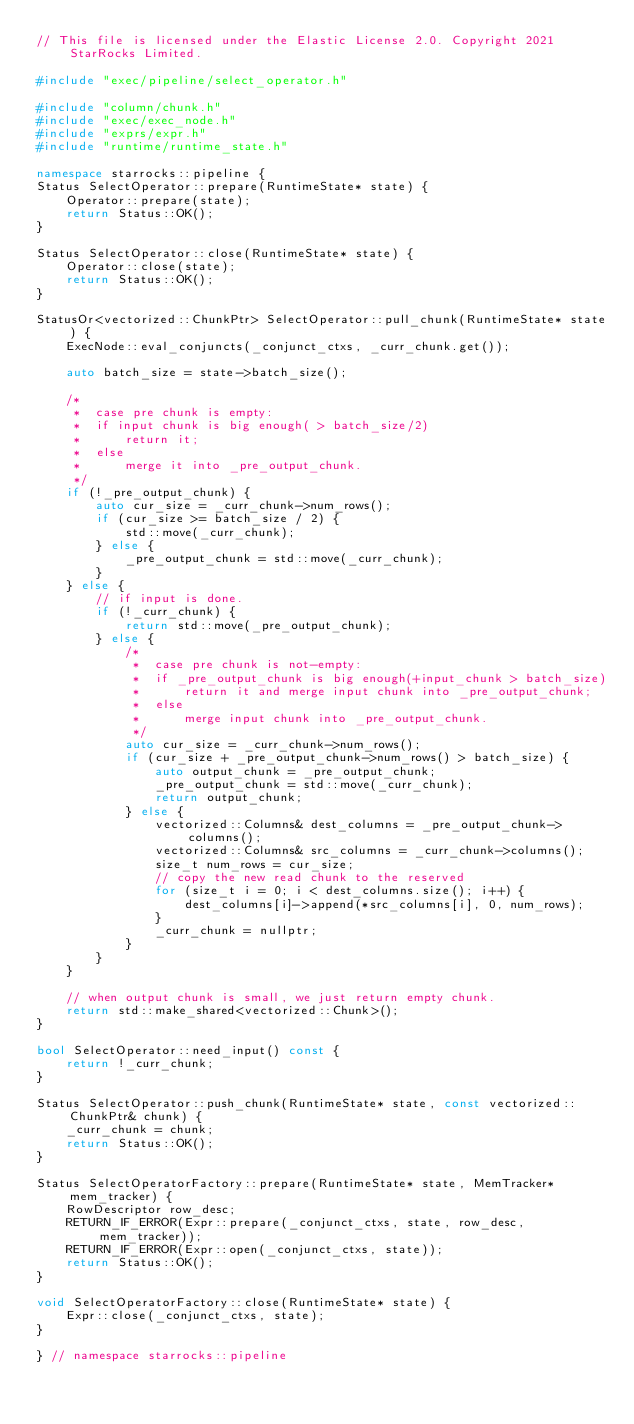<code> <loc_0><loc_0><loc_500><loc_500><_C++_>// This file is licensed under the Elastic License 2.0. Copyright 2021 StarRocks Limited.

#include "exec/pipeline/select_operator.h"

#include "column/chunk.h"
#include "exec/exec_node.h"
#include "exprs/expr.h"
#include "runtime/runtime_state.h"

namespace starrocks::pipeline {
Status SelectOperator::prepare(RuntimeState* state) {
    Operator::prepare(state);
    return Status::OK();
}

Status SelectOperator::close(RuntimeState* state) {
    Operator::close(state);
    return Status::OK();
}

StatusOr<vectorized::ChunkPtr> SelectOperator::pull_chunk(RuntimeState* state) {
    ExecNode::eval_conjuncts(_conjunct_ctxs, _curr_chunk.get());

    auto batch_size = state->batch_size();

    /*
     *  case pre chunk is empty:
     *  if input chunk is big enough( > batch_size/2)
     *      return it;
     *  else 
     *      merge it into _pre_output_chunk.
     */
    if (!_pre_output_chunk) {
        auto cur_size = _curr_chunk->num_rows();
        if (cur_size >= batch_size / 2) {
            std::move(_curr_chunk);
        } else {
            _pre_output_chunk = std::move(_curr_chunk);
        }
    } else {
        // if input is done.
        if (!_curr_chunk) {
            return std::move(_pre_output_chunk);
        } else {
            /*
             *  case pre chunk is not-empty:
             *  if _pre_output_chunk is big enough(+input_chunk > batch_size)
             *      return it and merge input chunk into _pre_output_chunk;
             *  else 
             *      merge input chunk into _pre_output_chunk.
             */
            auto cur_size = _curr_chunk->num_rows();
            if (cur_size + _pre_output_chunk->num_rows() > batch_size) {
                auto output_chunk = _pre_output_chunk;
                _pre_output_chunk = std::move(_curr_chunk);
                return output_chunk;
            } else {
                vectorized::Columns& dest_columns = _pre_output_chunk->columns();
                vectorized::Columns& src_columns = _curr_chunk->columns();
                size_t num_rows = cur_size;
                // copy the new read chunk to the reserved
                for (size_t i = 0; i < dest_columns.size(); i++) {
                    dest_columns[i]->append(*src_columns[i], 0, num_rows);
                }
                _curr_chunk = nullptr;
            }
        }
    }

    // when output chunk is small, we just return empty chunk.
    return std::make_shared<vectorized::Chunk>();
}

bool SelectOperator::need_input() const {
    return !_curr_chunk;
}

Status SelectOperator::push_chunk(RuntimeState* state, const vectorized::ChunkPtr& chunk) {
    _curr_chunk = chunk;
    return Status::OK();
}

Status SelectOperatorFactory::prepare(RuntimeState* state, MemTracker* mem_tracker) {
    RowDescriptor row_desc;
    RETURN_IF_ERROR(Expr::prepare(_conjunct_ctxs, state, row_desc, mem_tracker));
    RETURN_IF_ERROR(Expr::open(_conjunct_ctxs, state));
    return Status::OK();
}

void SelectOperatorFactory::close(RuntimeState* state) {
    Expr::close(_conjunct_ctxs, state);
}

} // namespace starrocks::pipeline
</code> 